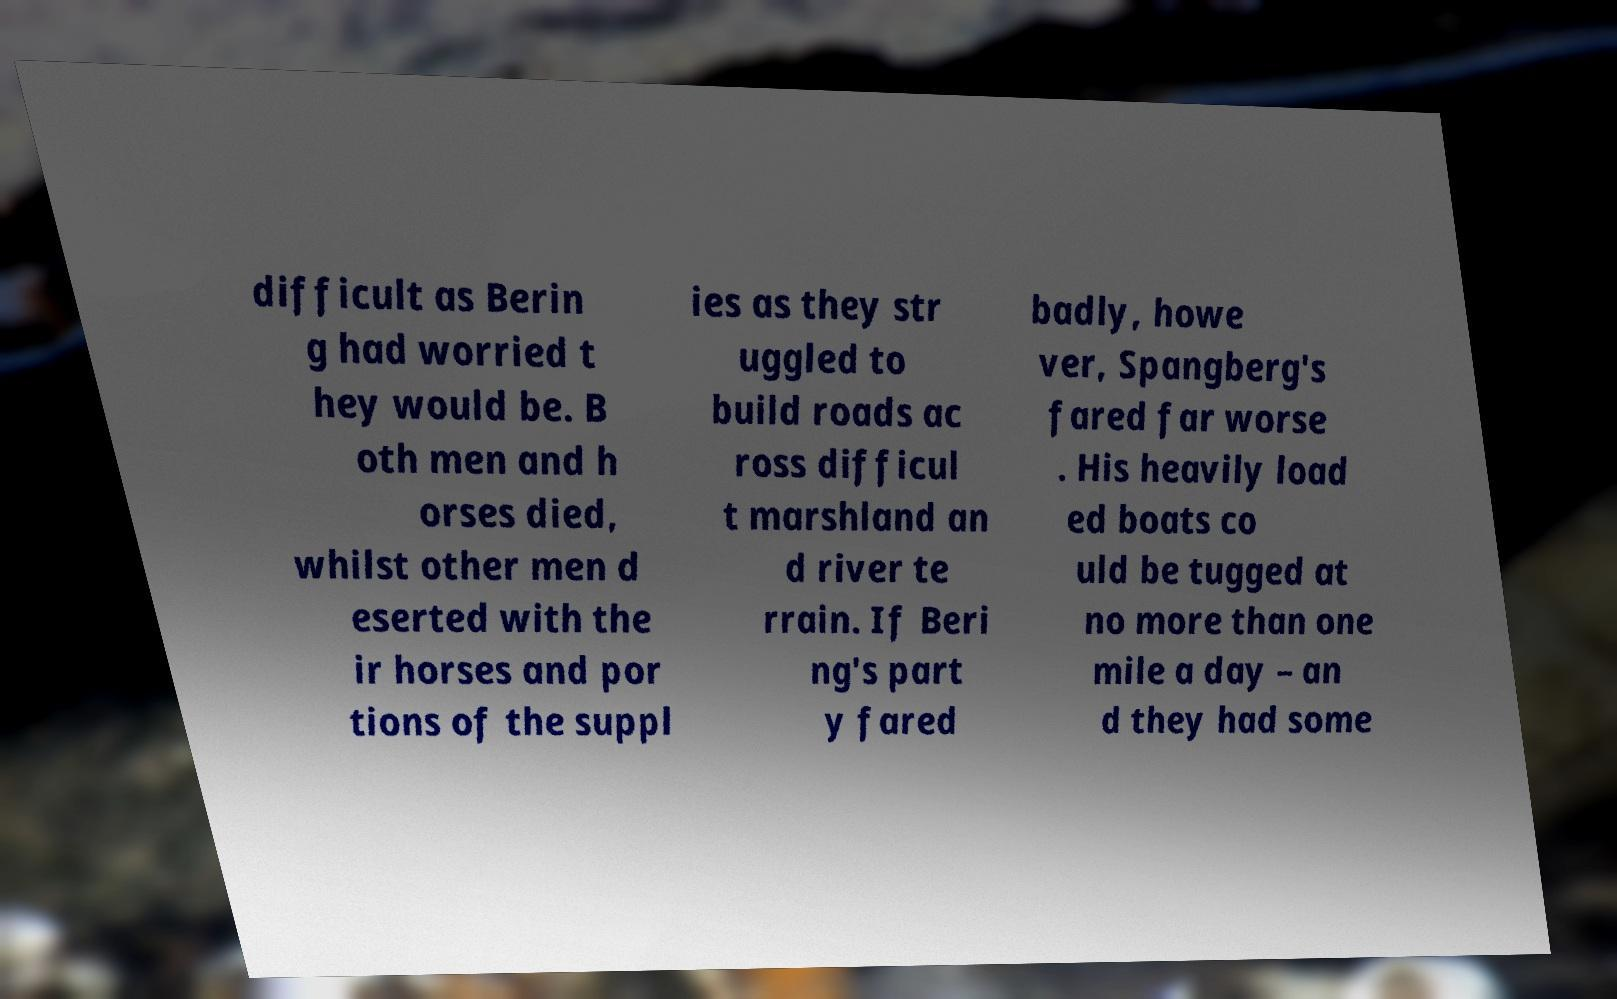Could you assist in decoding the text presented in this image and type it out clearly? difficult as Berin g had worried t hey would be. B oth men and h orses died, whilst other men d eserted with the ir horses and por tions of the suppl ies as they str uggled to build roads ac ross difficul t marshland an d river te rrain. If Beri ng's part y fared badly, howe ver, Spangberg's fared far worse . His heavily load ed boats co uld be tugged at no more than one mile a day – an d they had some 